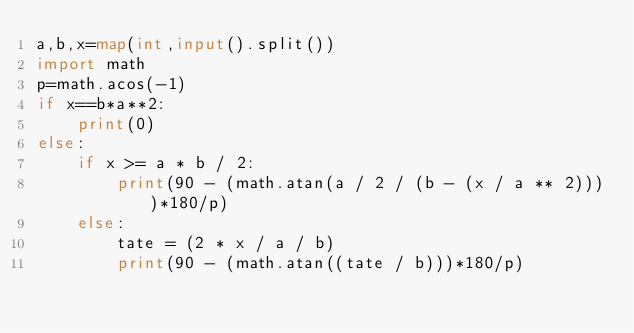Convert code to text. <code><loc_0><loc_0><loc_500><loc_500><_Python_>a,b,x=map(int,input().split())
import math
p=math.acos(-1)
if x==b*a**2:
    print(0)
else:
    if x >= a * b / 2:
        print(90 - (math.atan(a / 2 / (b - (x / a ** 2))))*180/p)
    else:
        tate = (2 * x / a / b)
        print(90 - (math.atan((tate / b)))*180/p)
        </code> 